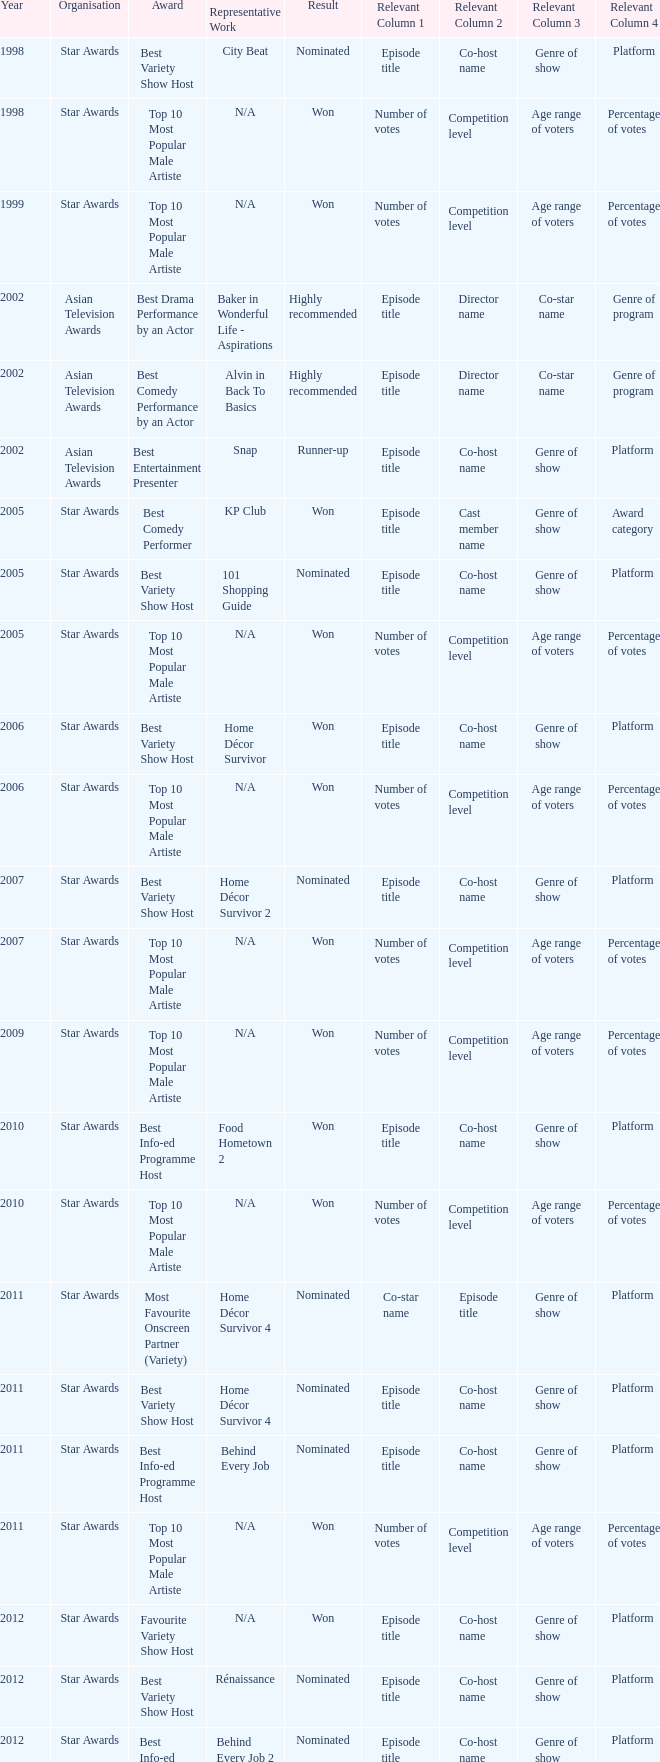What is the name of the award in a year more than 2005, and the Result of nominated? Best Variety Show Host, Most Favourite Onscreen Partner (Variety), Best Variety Show Host, Best Info-ed Programme Host, Best Variety Show Host, Best Info-ed Programme Host, Best Info-Ed Programme Host, Best Variety Show Host. 